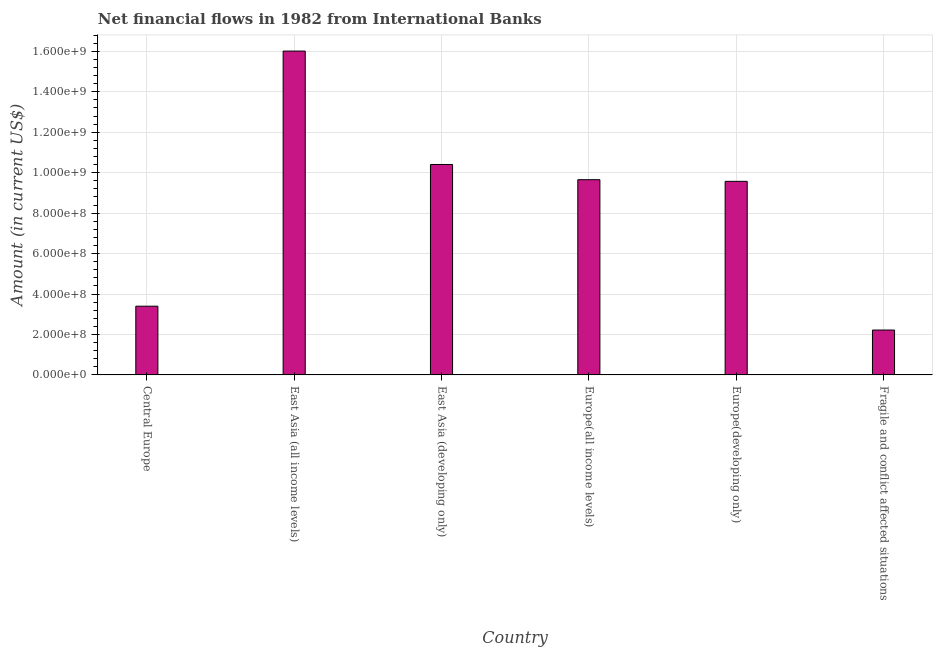Does the graph contain any zero values?
Provide a succinct answer. No. Does the graph contain grids?
Your answer should be compact. Yes. What is the title of the graph?
Your answer should be compact. Net financial flows in 1982 from International Banks. What is the label or title of the X-axis?
Make the answer very short. Country. What is the label or title of the Y-axis?
Make the answer very short. Amount (in current US$). What is the net financial flows from ibrd in Fragile and conflict affected situations?
Make the answer very short. 2.22e+08. Across all countries, what is the maximum net financial flows from ibrd?
Keep it short and to the point. 1.60e+09. Across all countries, what is the minimum net financial flows from ibrd?
Your answer should be compact. 2.22e+08. In which country was the net financial flows from ibrd maximum?
Ensure brevity in your answer.  East Asia (all income levels). In which country was the net financial flows from ibrd minimum?
Provide a short and direct response. Fragile and conflict affected situations. What is the sum of the net financial flows from ibrd?
Give a very brief answer. 5.13e+09. What is the difference between the net financial flows from ibrd in Central Europe and East Asia (developing only)?
Offer a very short reply. -7.01e+08. What is the average net financial flows from ibrd per country?
Offer a very short reply. 8.54e+08. What is the median net financial flows from ibrd?
Keep it short and to the point. 9.61e+08. What is the ratio of the net financial flows from ibrd in Central Europe to that in East Asia (all income levels)?
Keep it short and to the point. 0.21. Is the difference between the net financial flows from ibrd in Europe(all income levels) and Fragile and conflict affected situations greater than the difference between any two countries?
Offer a terse response. No. What is the difference between the highest and the second highest net financial flows from ibrd?
Your answer should be compact. 5.61e+08. What is the difference between the highest and the lowest net financial flows from ibrd?
Ensure brevity in your answer.  1.38e+09. In how many countries, is the net financial flows from ibrd greater than the average net financial flows from ibrd taken over all countries?
Ensure brevity in your answer.  4. Are all the bars in the graph horizontal?
Keep it short and to the point. No. What is the difference between two consecutive major ticks on the Y-axis?
Keep it short and to the point. 2.00e+08. Are the values on the major ticks of Y-axis written in scientific E-notation?
Ensure brevity in your answer.  Yes. What is the Amount (in current US$) in Central Europe?
Your answer should be very brief. 3.40e+08. What is the Amount (in current US$) in East Asia (all income levels)?
Make the answer very short. 1.60e+09. What is the Amount (in current US$) of East Asia (developing only)?
Your response must be concise. 1.04e+09. What is the Amount (in current US$) in Europe(all income levels)?
Offer a very short reply. 9.65e+08. What is the Amount (in current US$) in Europe(developing only)?
Provide a succinct answer. 9.57e+08. What is the Amount (in current US$) in Fragile and conflict affected situations?
Your answer should be compact. 2.22e+08. What is the difference between the Amount (in current US$) in Central Europe and East Asia (all income levels)?
Ensure brevity in your answer.  -1.26e+09. What is the difference between the Amount (in current US$) in Central Europe and East Asia (developing only)?
Give a very brief answer. -7.01e+08. What is the difference between the Amount (in current US$) in Central Europe and Europe(all income levels)?
Offer a terse response. -6.26e+08. What is the difference between the Amount (in current US$) in Central Europe and Europe(developing only)?
Give a very brief answer. -6.17e+08. What is the difference between the Amount (in current US$) in Central Europe and Fragile and conflict affected situations?
Give a very brief answer. 1.18e+08. What is the difference between the Amount (in current US$) in East Asia (all income levels) and East Asia (developing only)?
Provide a short and direct response. 5.61e+08. What is the difference between the Amount (in current US$) in East Asia (all income levels) and Europe(all income levels)?
Your answer should be compact. 6.36e+08. What is the difference between the Amount (in current US$) in East Asia (all income levels) and Europe(developing only)?
Provide a short and direct response. 6.44e+08. What is the difference between the Amount (in current US$) in East Asia (all income levels) and Fragile and conflict affected situations?
Make the answer very short. 1.38e+09. What is the difference between the Amount (in current US$) in East Asia (developing only) and Europe(all income levels)?
Give a very brief answer. 7.53e+07. What is the difference between the Amount (in current US$) in East Asia (developing only) and Europe(developing only)?
Give a very brief answer. 8.34e+07. What is the difference between the Amount (in current US$) in East Asia (developing only) and Fragile and conflict affected situations?
Your response must be concise. 8.19e+08. What is the difference between the Amount (in current US$) in Europe(all income levels) and Europe(developing only)?
Make the answer very short. 8.10e+06. What is the difference between the Amount (in current US$) in Europe(all income levels) and Fragile and conflict affected situations?
Provide a short and direct response. 7.43e+08. What is the difference between the Amount (in current US$) in Europe(developing only) and Fragile and conflict affected situations?
Keep it short and to the point. 7.35e+08. What is the ratio of the Amount (in current US$) in Central Europe to that in East Asia (all income levels)?
Keep it short and to the point. 0.21. What is the ratio of the Amount (in current US$) in Central Europe to that in East Asia (developing only)?
Give a very brief answer. 0.33. What is the ratio of the Amount (in current US$) in Central Europe to that in Europe(all income levels)?
Ensure brevity in your answer.  0.35. What is the ratio of the Amount (in current US$) in Central Europe to that in Europe(developing only)?
Keep it short and to the point. 0.35. What is the ratio of the Amount (in current US$) in Central Europe to that in Fragile and conflict affected situations?
Your response must be concise. 1.53. What is the ratio of the Amount (in current US$) in East Asia (all income levels) to that in East Asia (developing only)?
Provide a succinct answer. 1.54. What is the ratio of the Amount (in current US$) in East Asia (all income levels) to that in Europe(all income levels)?
Your answer should be compact. 1.66. What is the ratio of the Amount (in current US$) in East Asia (all income levels) to that in Europe(developing only)?
Your answer should be very brief. 1.67. What is the ratio of the Amount (in current US$) in East Asia (all income levels) to that in Fragile and conflict affected situations?
Keep it short and to the point. 7.22. What is the ratio of the Amount (in current US$) in East Asia (developing only) to that in Europe(all income levels)?
Ensure brevity in your answer.  1.08. What is the ratio of the Amount (in current US$) in East Asia (developing only) to that in Europe(developing only)?
Your response must be concise. 1.09. What is the ratio of the Amount (in current US$) in East Asia (developing only) to that in Fragile and conflict affected situations?
Provide a short and direct response. 4.69. What is the ratio of the Amount (in current US$) in Europe(all income levels) to that in Europe(developing only)?
Make the answer very short. 1.01. What is the ratio of the Amount (in current US$) in Europe(all income levels) to that in Fragile and conflict affected situations?
Your answer should be compact. 4.35. What is the ratio of the Amount (in current US$) in Europe(developing only) to that in Fragile and conflict affected situations?
Your response must be concise. 4.31. 